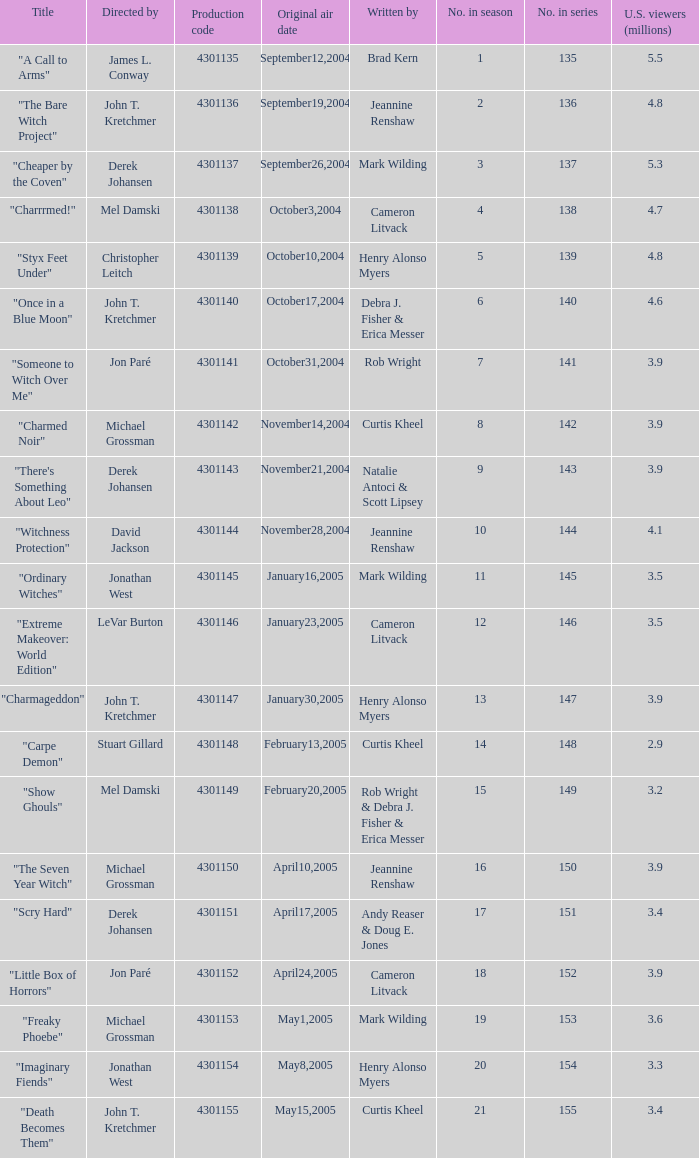What was the name of the episode that got 3.3 (millions) of u.s viewers? "Imaginary Fiends". 